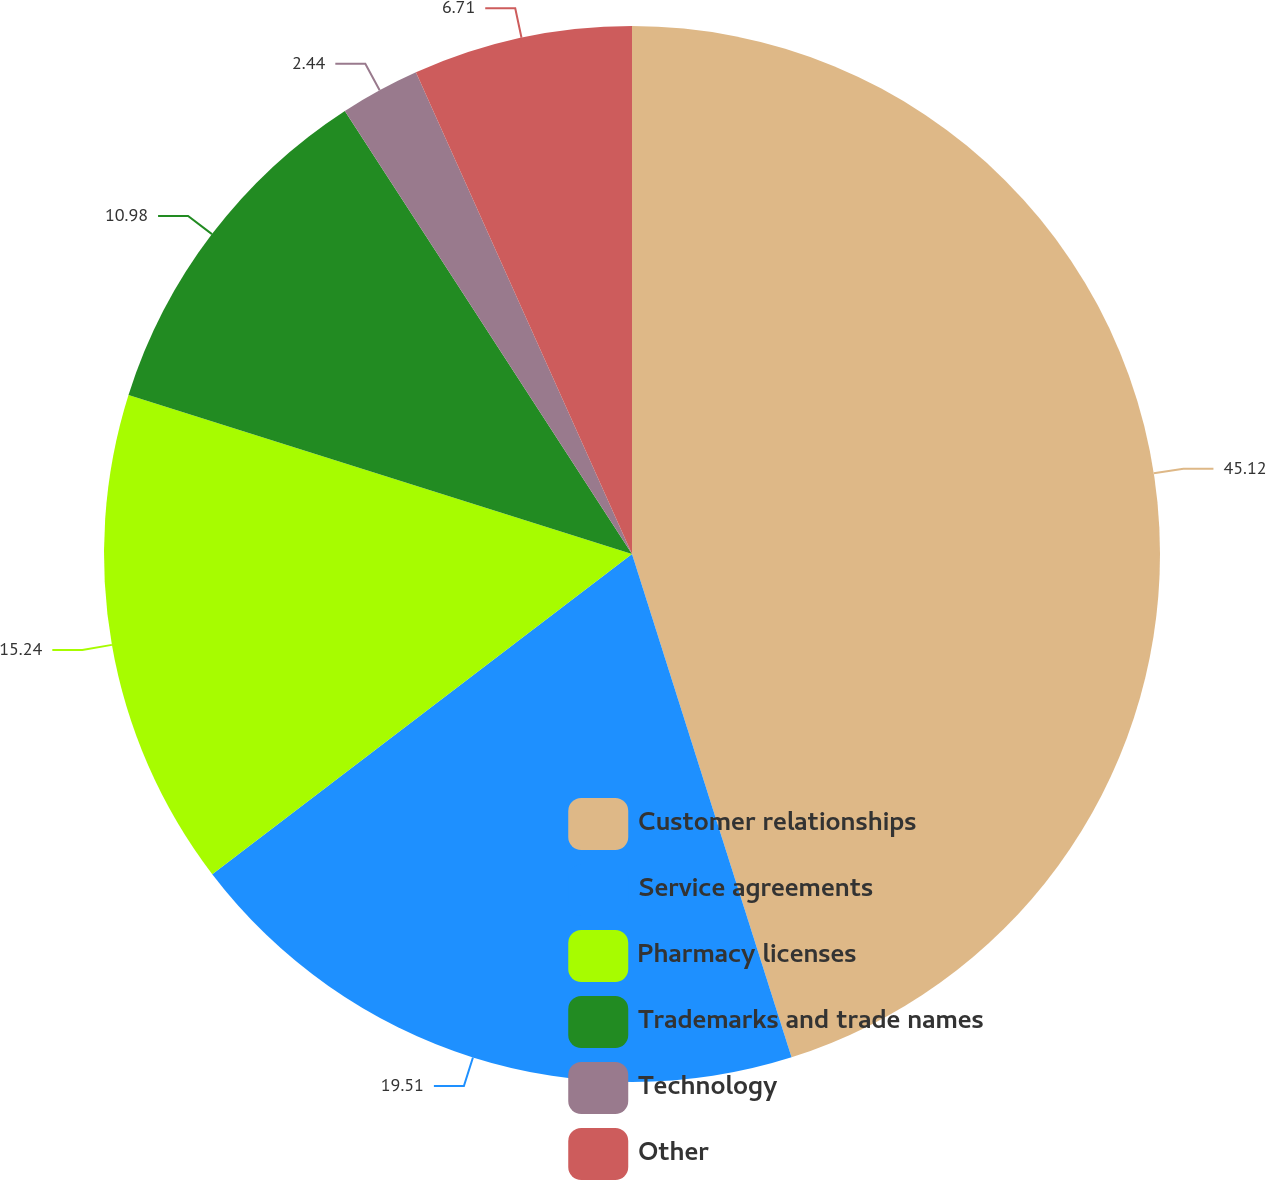Convert chart to OTSL. <chart><loc_0><loc_0><loc_500><loc_500><pie_chart><fcel>Customer relationships<fcel>Service agreements<fcel>Pharmacy licenses<fcel>Trademarks and trade names<fcel>Technology<fcel>Other<nl><fcel>45.11%<fcel>19.51%<fcel>15.24%<fcel>10.98%<fcel>2.44%<fcel>6.71%<nl></chart> 